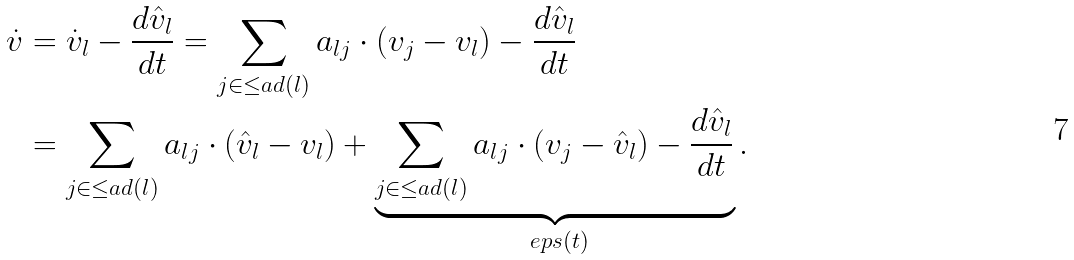<formula> <loc_0><loc_0><loc_500><loc_500>\dot { v } & = \dot { v } _ { l } - \frac { d \hat { v } _ { l } } { d t } = \sum _ { j \in \leq a d ( l ) } a _ { l j } \cdot ( v _ { j } - v _ { l } ) - \frac { d \hat { v } _ { l } } { d t } \\ & = \sum _ { j \in \leq a d ( l ) } a _ { l j } \cdot ( \hat { v } _ { l } - v _ { l } ) + \underbrace { \sum _ { j \in \leq a d ( l ) } a _ { l j } \cdot ( v _ { j } - \hat { v } _ { l } ) - \frac { d \hat { v } _ { l } } { d t } } _ { \ e p s ( t ) } .</formula> 